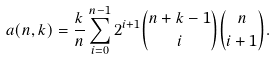Convert formula to latex. <formula><loc_0><loc_0><loc_500><loc_500>a ( n , k ) = \frac { k } { n } \sum _ { i = 0 } ^ { n - 1 } 2 ^ { i + 1 } { n + k - 1 \choose i } { n \choose i + 1 } .</formula> 